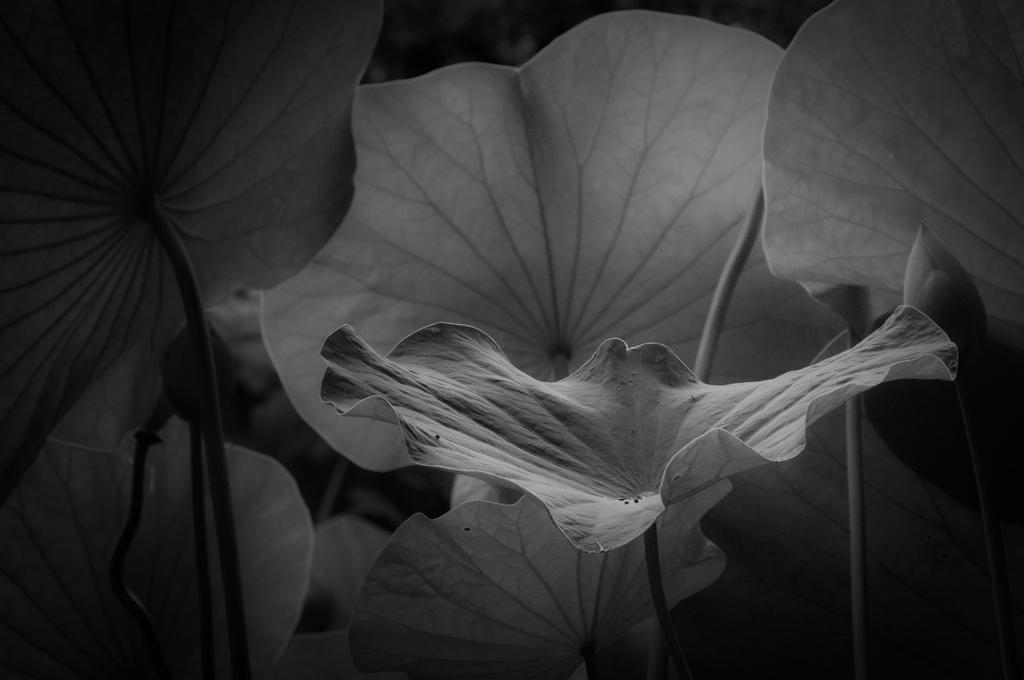Can you describe this image briefly? At the bottom of this image, there are plants having leaves. And the background is dark in color. 